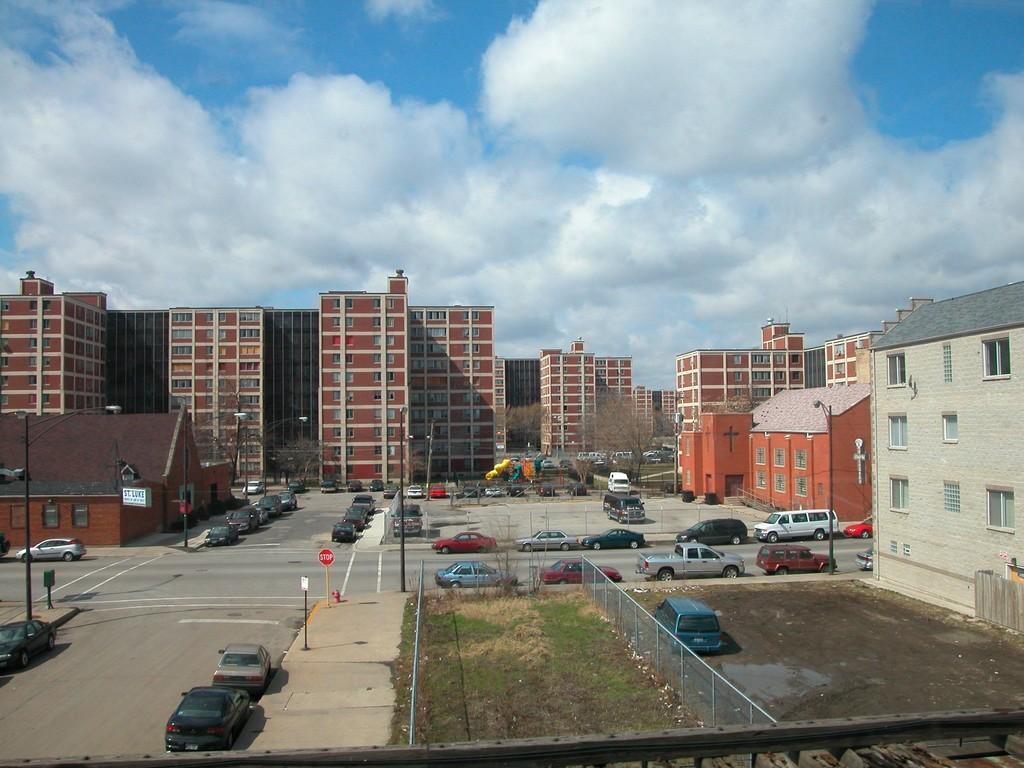Please provide a concise description of this image. In this image we can see buildings, trees, motor vehicles on the road and in the parking slots, fences, sign boards, street poles, street lights and sky with clouds. 